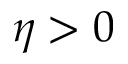Convert formula to latex. <formula><loc_0><loc_0><loc_500><loc_500>\eta > 0</formula> 